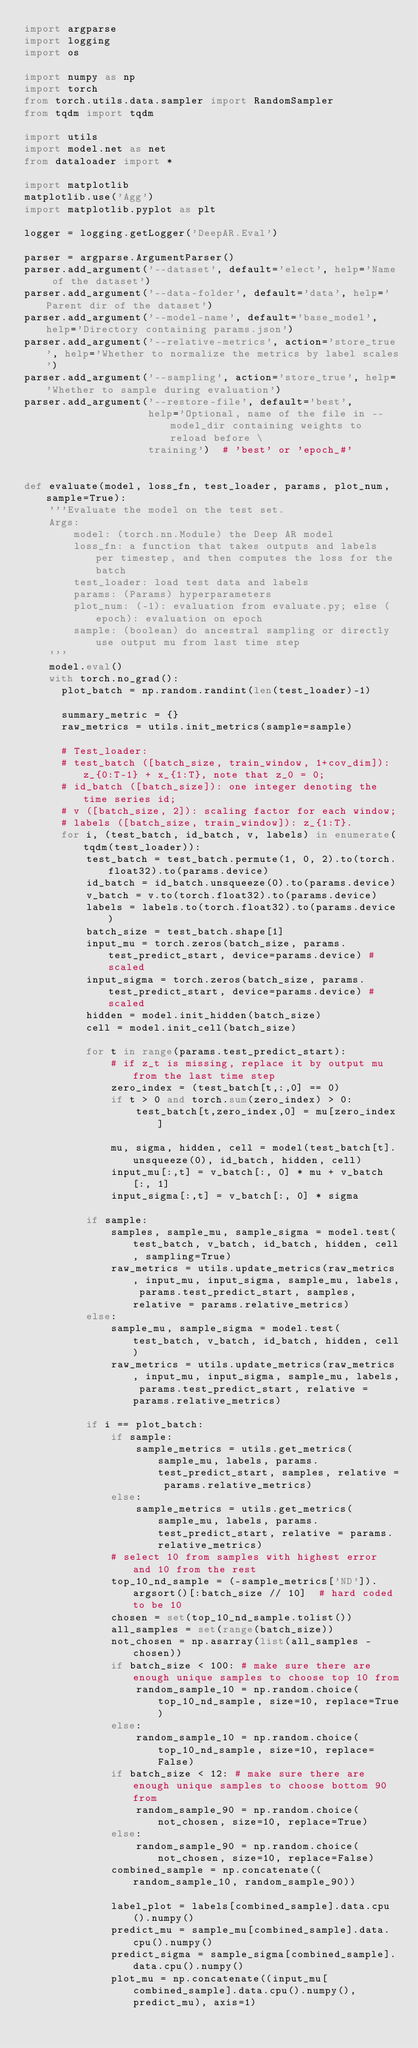Convert code to text. <code><loc_0><loc_0><loc_500><loc_500><_Python_>import argparse
import logging
import os

import numpy as np
import torch
from torch.utils.data.sampler import RandomSampler
from tqdm import tqdm

import utils
import model.net as net
from dataloader import *

import matplotlib
matplotlib.use('Agg')
import matplotlib.pyplot as plt

logger = logging.getLogger('DeepAR.Eval')

parser = argparse.ArgumentParser()
parser.add_argument('--dataset', default='elect', help='Name of the dataset')
parser.add_argument('--data-folder', default='data', help='Parent dir of the dataset')
parser.add_argument('--model-name', default='base_model', help='Directory containing params.json')
parser.add_argument('--relative-metrics', action='store_true', help='Whether to normalize the metrics by label scales')
parser.add_argument('--sampling', action='store_true', help='Whether to sample during evaluation')
parser.add_argument('--restore-file', default='best',
                    help='Optional, name of the file in --model_dir containing weights to reload before \
                    training')  # 'best' or 'epoch_#'


def evaluate(model, loss_fn, test_loader, params, plot_num, sample=True):
    '''Evaluate the model on the test set.
    Args:
        model: (torch.nn.Module) the Deep AR model
        loss_fn: a function that takes outputs and labels per timestep, and then computes the loss for the batch
        test_loader: load test data and labels
        params: (Params) hyperparameters
        plot_num: (-1): evaluation from evaluate.py; else (epoch): evaluation on epoch
        sample: (boolean) do ancestral sampling or directly use output mu from last time step
    '''
    model.eval()
    with torch.no_grad():
      plot_batch = np.random.randint(len(test_loader)-1)

      summary_metric = {}
      raw_metrics = utils.init_metrics(sample=sample)

      # Test_loader: 
      # test_batch ([batch_size, train_window, 1+cov_dim]): z_{0:T-1} + x_{1:T}, note that z_0 = 0;
      # id_batch ([batch_size]): one integer denoting the time series id;
      # v ([batch_size, 2]): scaling factor for each window;
      # labels ([batch_size, train_window]): z_{1:T}.
      for i, (test_batch, id_batch, v, labels) in enumerate(tqdm(test_loader)):
          test_batch = test_batch.permute(1, 0, 2).to(torch.float32).to(params.device)
          id_batch = id_batch.unsqueeze(0).to(params.device)
          v_batch = v.to(torch.float32).to(params.device)
          labels = labels.to(torch.float32).to(params.device)
          batch_size = test_batch.shape[1]
          input_mu = torch.zeros(batch_size, params.test_predict_start, device=params.device) # scaled
          input_sigma = torch.zeros(batch_size, params.test_predict_start, device=params.device) # scaled
          hidden = model.init_hidden(batch_size)
          cell = model.init_cell(batch_size)

          for t in range(params.test_predict_start):
              # if z_t is missing, replace it by output mu from the last time step
              zero_index = (test_batch[t,:,0] == 0)
              if t > 0 and torch.sum(zero_index) > 0:
                  test_batch[t,zero_index,0] = mu[zero_index]

              mu, sigma, hidden, cell = model(test_batch[t].unsqueeze(0), id_batch, hidden, cell)
              input_mu[:,t] = v_batch[:, 0] * mu + v_batch[:, 1]
              input_sigma[:,t] = v_batch[:, 0] * sigma

          if sample:
              samples, sample_mu, sample_sigma = model.test(test_batch, v_batch, id_batch, hidden, cell, sampling=True)
              raw_metrics = utils.update_metrics(raw_metrics, input_mu, input_sigma, sample_mu, labels, params.test_predict_start, samples, relative = params.relative_metrics)
          else:
              sample_mu, sample_sigma = model.test(test_batch, v_batch, id_batch, hidden, cell)
              raw_metrics = utils.update_metrics(raw_metrics, input_mu, input_sigma, sample_mu, labels, params.test_predict_start, relative = params.relative_metrics)

          if i == plot_batch:
              if sample:
                  sample_metrics = utils.get_metrics(sample_mu, labels, params.test_predict_start, samples, relative = params.relative_metrics)
              else:
                  sample_metrics = utils.get_metrics(sample_mu, labels, params.test_predict_start, relative = params.relative_metrics)                
              # select 10 from samples with highest error and 10 from the rest
              top_10_nd_sample = (-sample_metrics['ND']).argsort()[:batch_size // 10]  # hard coded to be 10
              chosen = set(top_10_nd_sample.tolist())
              all_samples = set(range(batch_size))
              not_chosen = np.asarray(list(all_samples - chosen))
              if batch_size < 100: # make sure there are enough unique samples to choose top 10 from
                  random_sample_10 = np.random.choice(top_10_nd_sample, size=10, replace=True)
              else:
                  random_sample_10 = np.random.choice(top_10_nd_sample, size=10, replace=False)
              if batch_size < 12: # make sure there are enough unique samples to choose bottom 90 from
                  random_sample_90 = np.random.choice(not_chosen, size=10, replace=True)
              else:
                  random_sample_90 = np.random.choice(not_chosen, size=10, replace=False)
              combined_sample = np.concatenate((random_sample_10, random_sample_90))

              label_plot = labels[combined_sample].data.cpu().numpy()
              predict_mu = sample_mu[combined_sample].data.cpu().numpy()
              predict_sigma = sample_sigma[combined_sample].data.cpu().numpy()
              plot_mu = np.concatenate((input_mu[combined_sample].data.cpu().numpy(), predict_mu), axis=1)</code> 